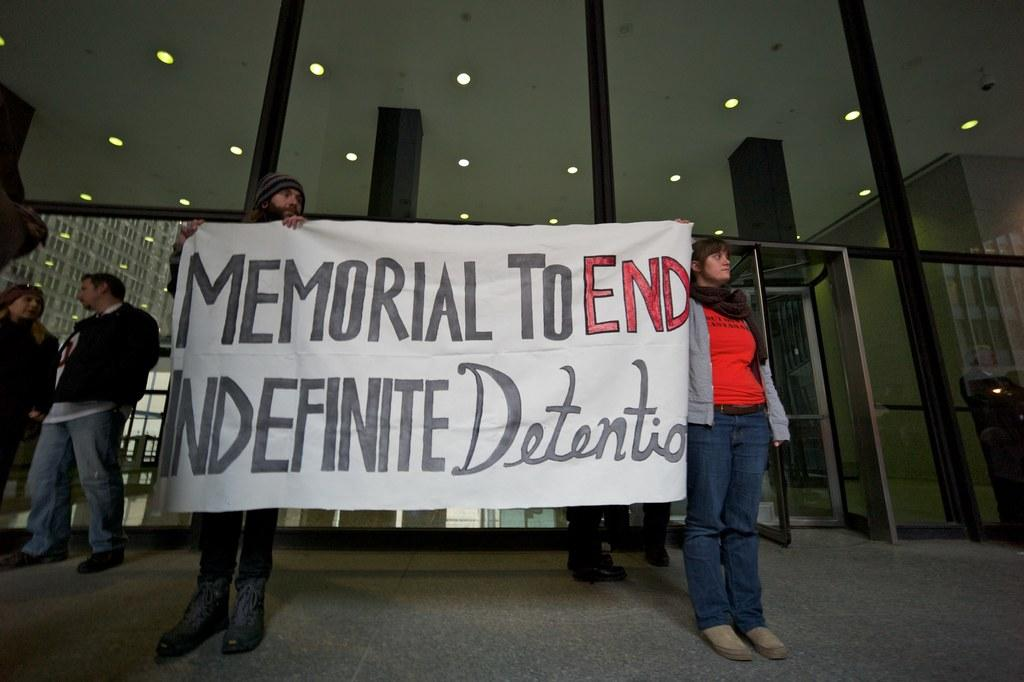Who are the two people in the center of the image? There is a man and a lady in the center of the image. What are the man and lady holding in the image? The man and lady are holding a banner. Can you describe the people in the background of the image? There are people standing in the background of the image. What can be seen at the top of the image? There are lights visible at the top of the image. What type of fang can be seen in the image? There is no fang present in the image. How many clams are visible in the image? There are no clams present in the image. 